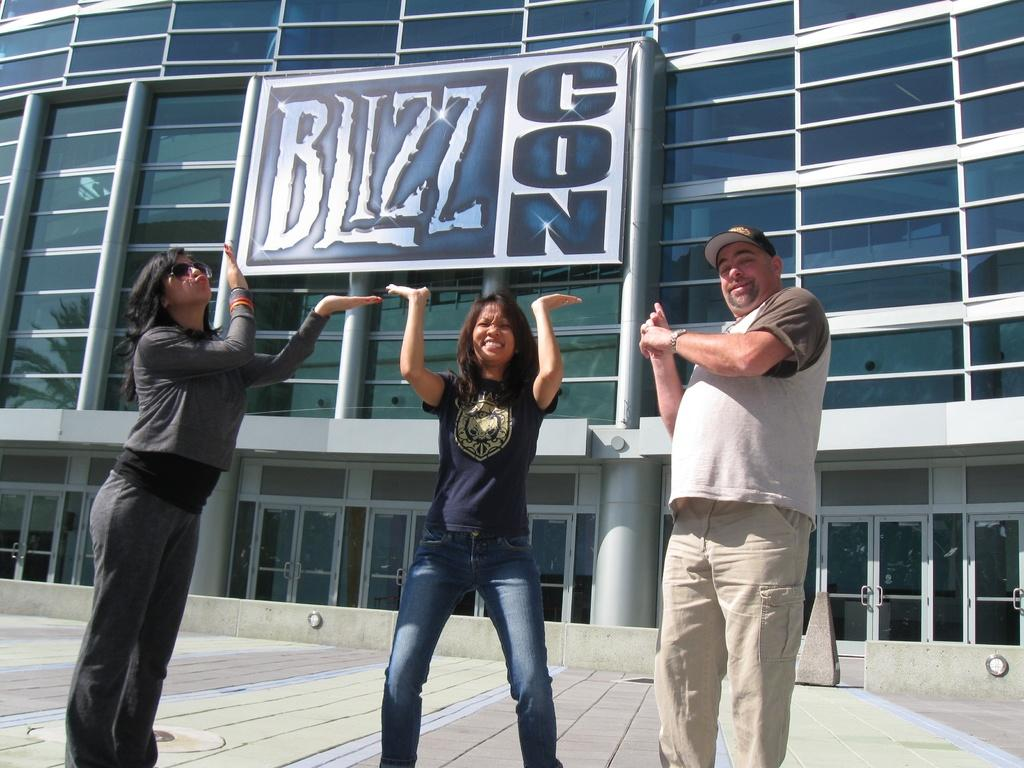How many people are in the image? There are a few people in the image. What can be seen in the background of the image? There is a building and a board with some text in the background of the image. What is visible on the ground in the image? The ground is visible in the image. Are there any cows wearing veils in the image? No, there are no cows or veils present in the image. 